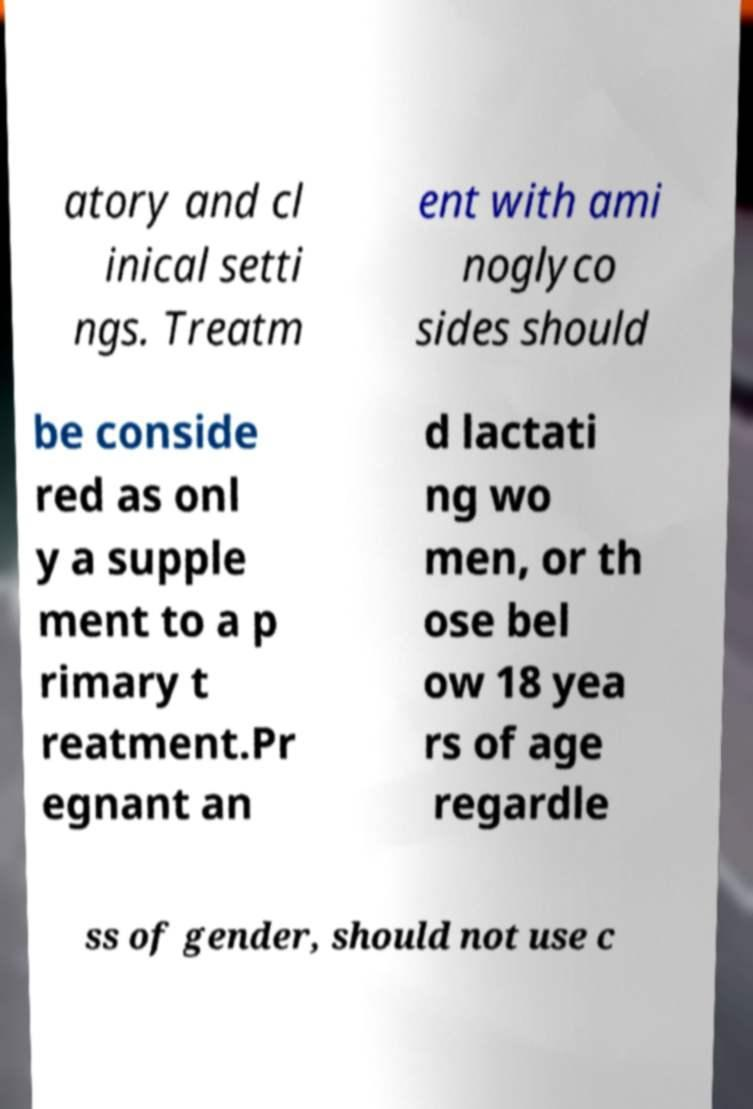I need the written content from this picture converted into text. Can you do that? atory and cl inical setti ngs. Treatm ent with ami noglyco sides should be conside red as onl y a supple ment to a p rimary t reatment.Pr egnant an d lactati ng wo men, or th ose bel ow 18 yea rs of age regardle ss of gender, should not use c 